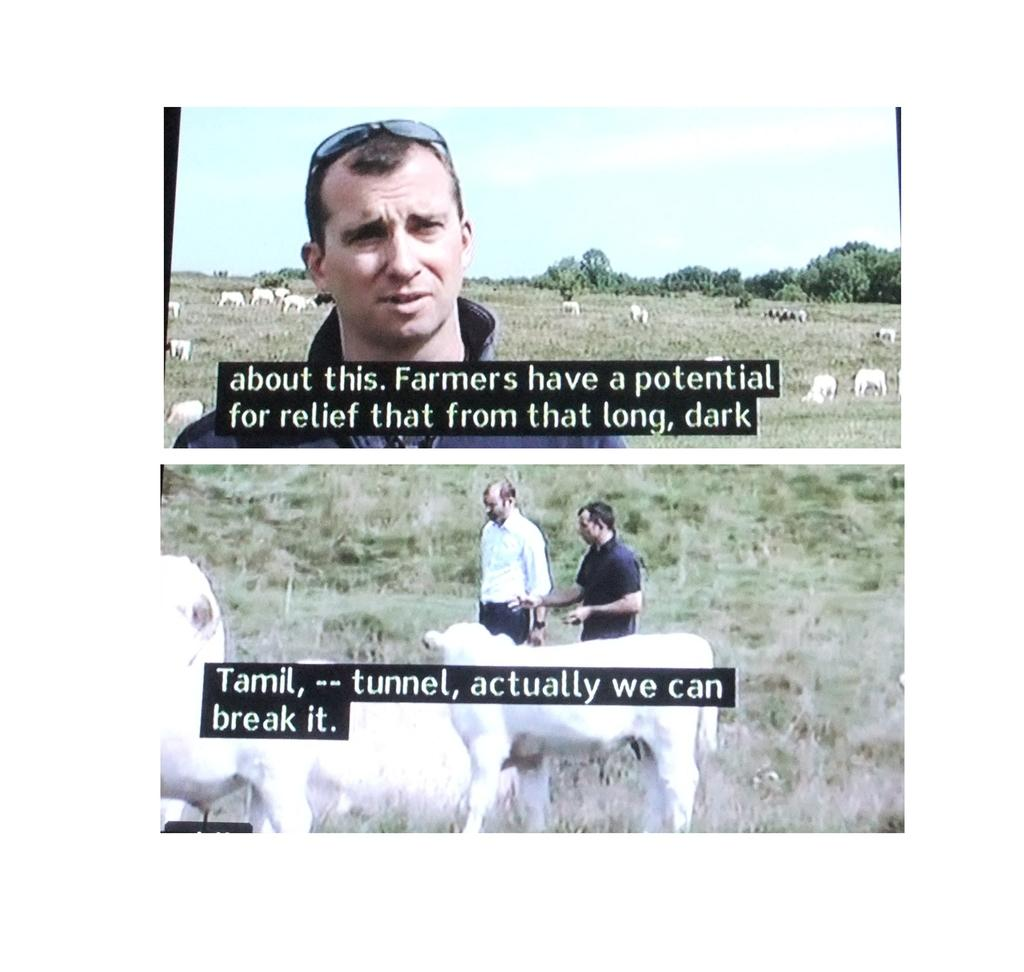What types of living beings are present in the image? There are people and animals in the image. What other elements can be seen in the image besides living beings? There are plants, trees, and text in the image. What is visible at the top of the image? The sky is visible at the top of the image. What hobbies do the goats in the image enjoy? There are no goats present in the image, so it is not possible to determine their hobbies. 